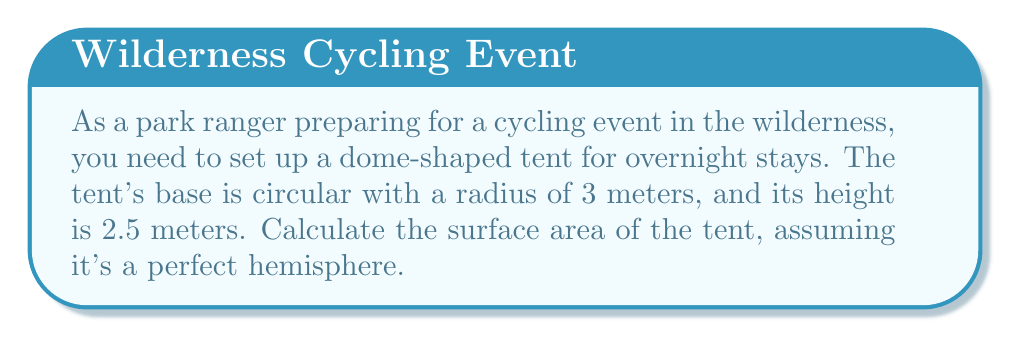Give your solution to this math problem. Let's approach this step-by-step:

1) The surface area of a hemisphere consists of two parts:
   a) The curved surface area
   b) The circular base area

2) For a hemisphere:
   - Curved surface area = $2\pi r^2$
   - Base area = $\pi r^2$
   where $r$ is the radius of the base

3) We need to find $r$. We know the base radius is 3m and the height is 2.5m.
   In a hemisphere, the radius is equal to the height.
   So, $r = 2.5$ meters

4) Now, let's calculate:
   a) Curved surface area = $2\pi r^2 = 2\pi (2.5)^2 = 2\pi(6.25) = 39.27$ sq meters
   b) Base area = $\pi r^2 = \pi (3)^2 = 9\pi = 28.27$ sq meters

5) Total surface area = Curved surface area + Base area
                      = $39.27 + 28.27 = 67.54$ sq meters

[asy]
import geometry;

size(200);
pair O=(0,0);
real r=3;
real h=2.5;

draw(circle(O,r));
draw((-r,0)--(r,0));
draw(O--(0,h));
draw(arc(O,r,0,180),dashed);

label("3m",(-r/2,0),S);
label("2.5m",(0,h/2),E);
[/asy]
Answer: 67.54 sq meters 